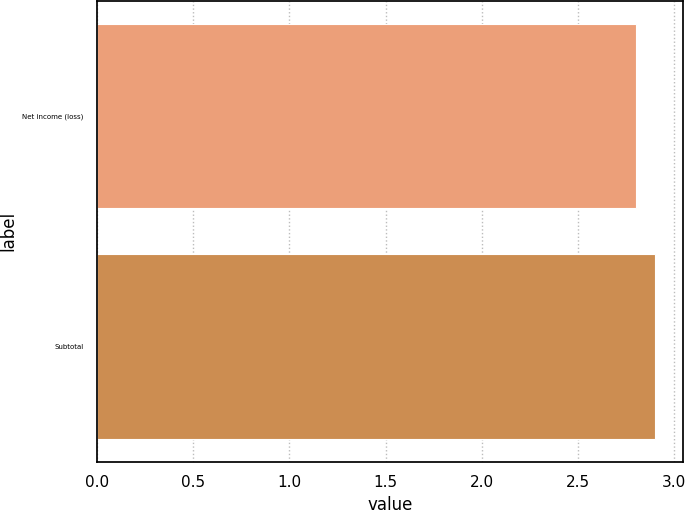Convert chart. <chart><loc_0><loc_0><loc_500><loc_500><bar_chart><fcel>Net income (loss)<fcel>Subtotal<nl><fcel>2.8<fcel>2.9<nl></chart> 